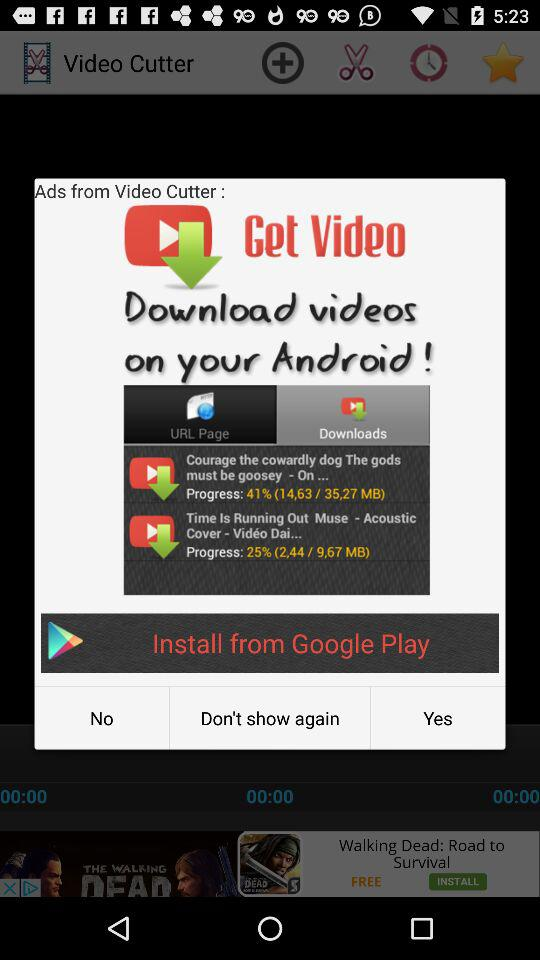How many videos are being downloaded?
Answer the question using a single word or phrase. 2 